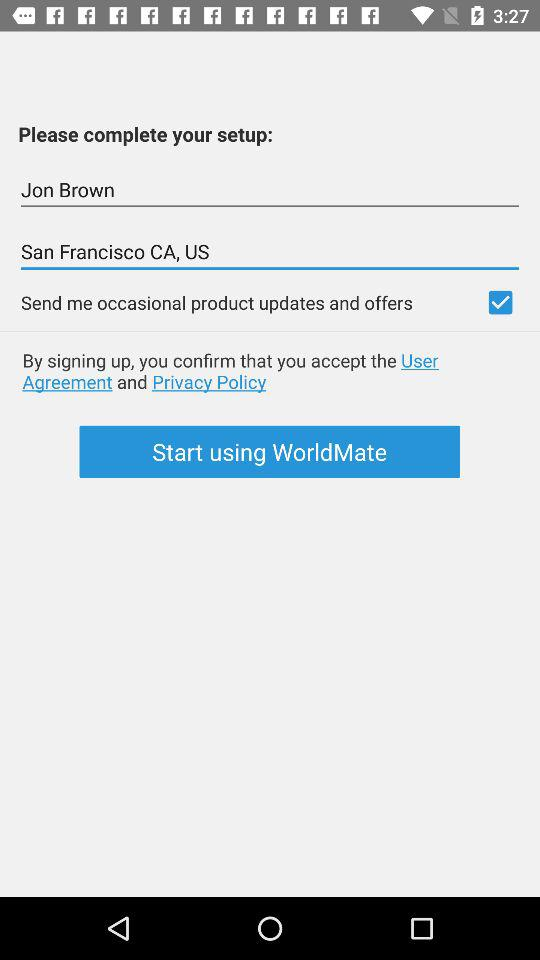What's the address of Jon Brown? The address is San Francisco CA, US. 